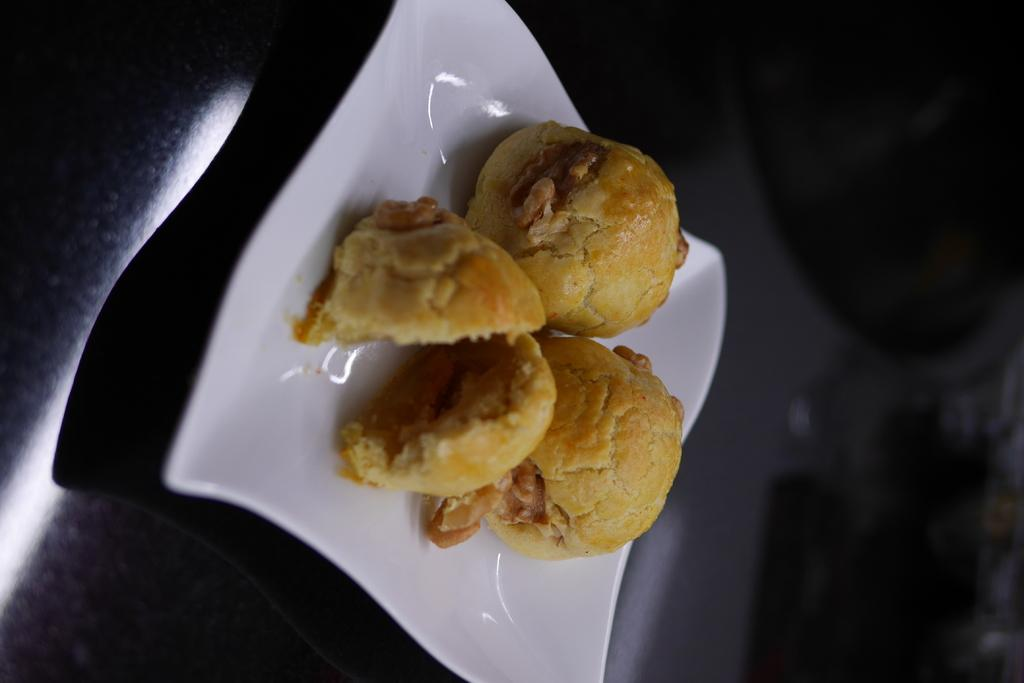What is the main object in the center of the image? There is a table in the center of the image. What is placed on the table? There is a plate on the table. What is in the plate? There is a food item in the plate. Where is the fan located in the image? There is no fan present in the image. What direction is the table facing in the image? The facts provided do not indicate the direction the table is facing, only that it is in the center of the image. 